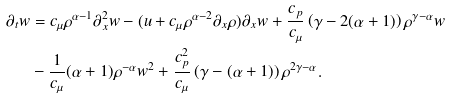Convert formula to latex. <formula><loc_0><loc_0><loc_500><loc_500>\partial _ { t } w & = c _ { \mu } \rho ^ { \alpha - 1 } \partial _ { x } ^ { 2 } w - ( u + c _ { \mu } \rho ^ { \alpha - 2 } \partial _ { x } \rho ) \partial _ { x } w + \frac { c _ { p } } { c _ { \mu } } \left ( \gamma - 2 ( \alpha + 1 ) \right ) \rho ^ { \gamma - \alpha } w \\ & - \frac { 1 } { c _ { \mu } } ( \alpha + 1 ) \rho ^ { - \alpha } w ^ { 2 } + \frac { c ^ { 2 } _ { p } } { c _ { \mu } } \left ( \gamma - ( \alpha + 1 ) \right ) \rho ^ { 2 \gamma - \alpha } .</formula> 